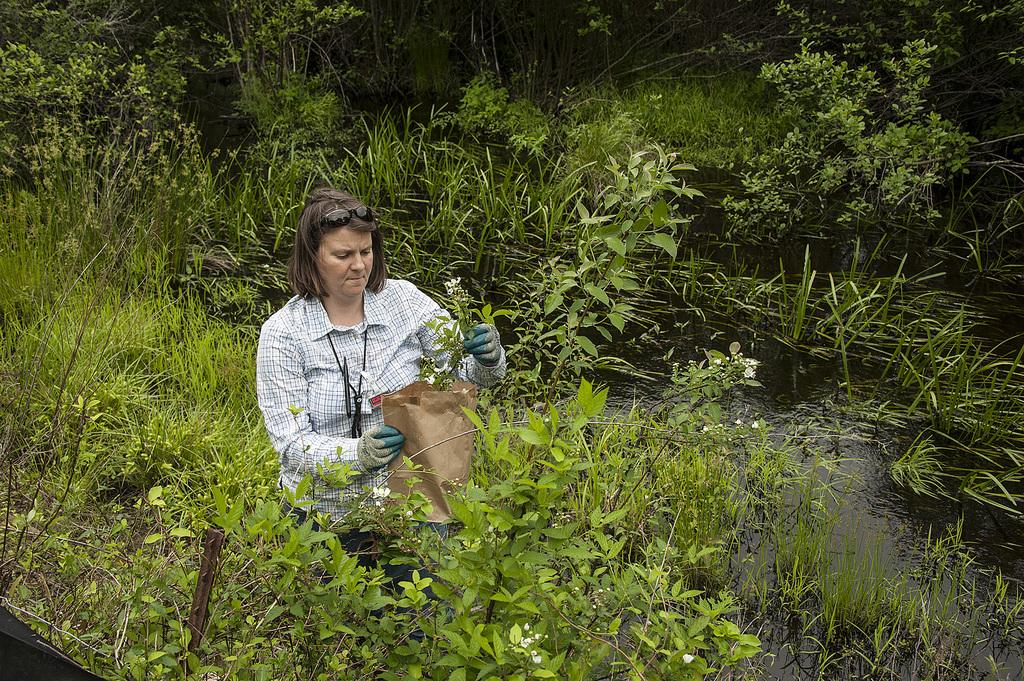What is the person in the image holding? The person is holding a plant and a paper bag. What else can be seen in the image besides the person? There are plants, trees, grass, and water visible in the image. What type of club does the person in the image belong to? There is no indication in the image that the person belongs to any club. Can you tell me how the grandfather in the image is feeling? There is no grandfather present in the image. 